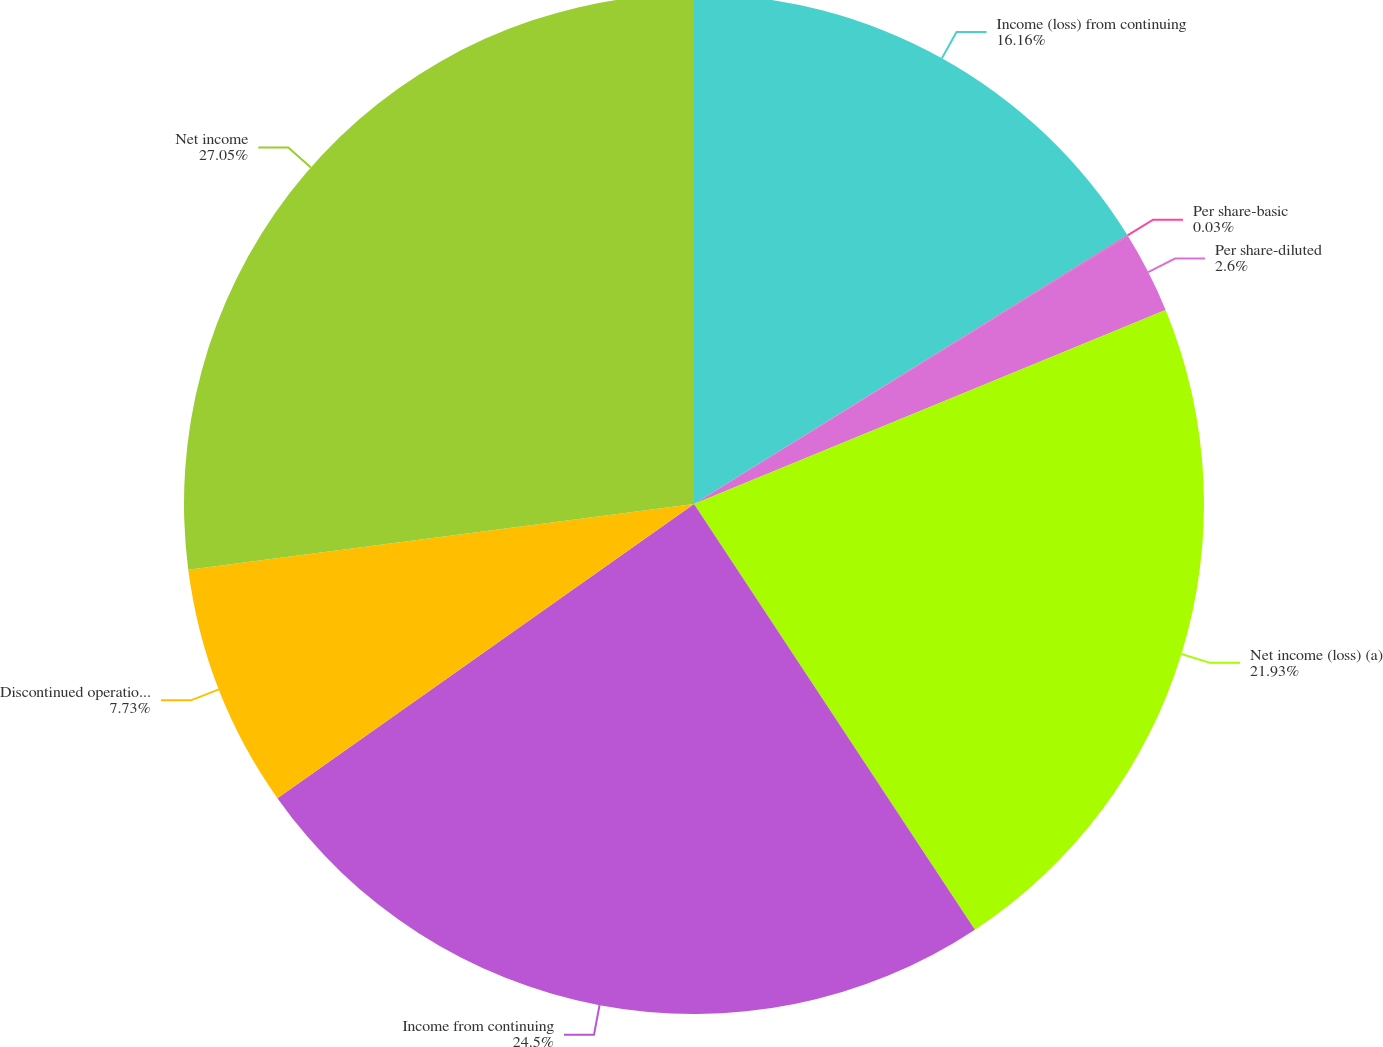Convert chart to OTSL. <chart><loc_0><loc_0><loc_500><loc_500><pie_chart><fcel>Income (loss) from continuing<fcel>Per share-basic<fcel>Per share-diluted<fcel>Net income (loss) (a)<fcel>Income from continuing<fcel>Discontinued operations net<fcel>Net income<nl><fcel>16.16%<fcel>0.03%<fcel>2.6%<fcel>21.93%<fcel>24.5%<fcel>7.73%<fcel>27.06%<nl></chart> 